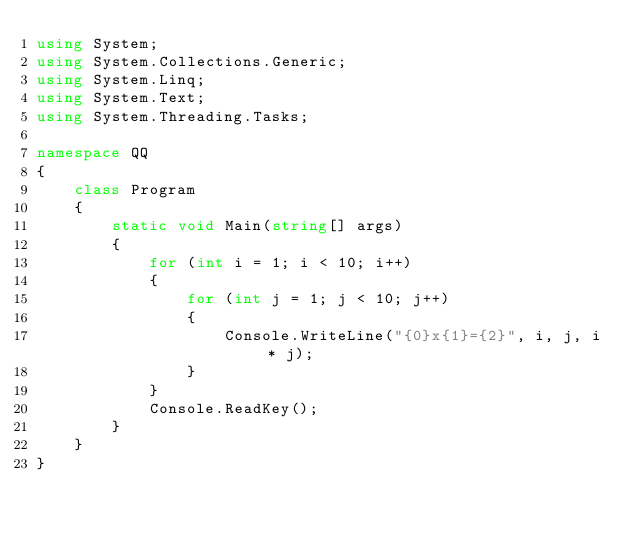<code> <loc_0><loc_0><loc_500><loc_500><_C#_>using System;
using System.Collections.Generic;
using System.Linq;
using System.Text;
using System.Threading.Tasks;

namespace QQ
{
    class Program
    {
        static void Main(string[] args)
        {
            for (int i = 1; i < 10; i++)
            {
                for (int j = 1; j < 10; j++)
                {
                    Console.WriteLine("{0}x{1}={2}", i, j, i * j);
                }
            }
            Console.ReadKey();
        }
    }
}</code> 